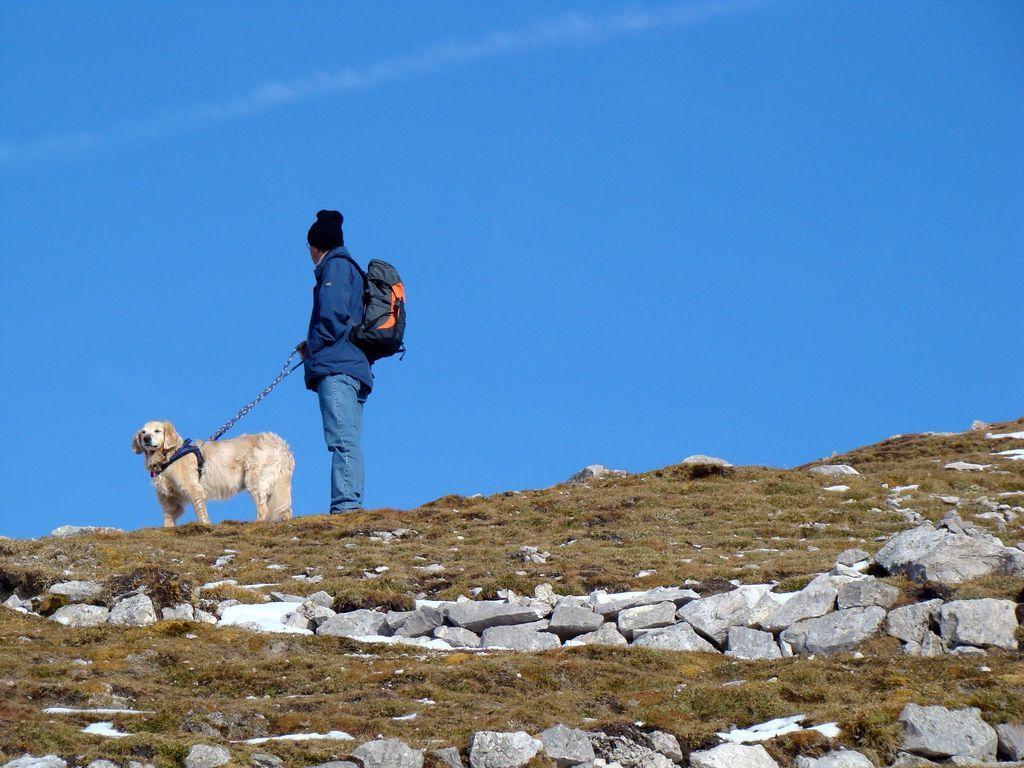Describe this image in one or two sentences. In this image we can see one person wearing a backpack standing and holding a dog belt. There is one dog with a blue belt, some grass on the ground, smoke line in the sky, some rocks on the ground and at the top there is the sky. 